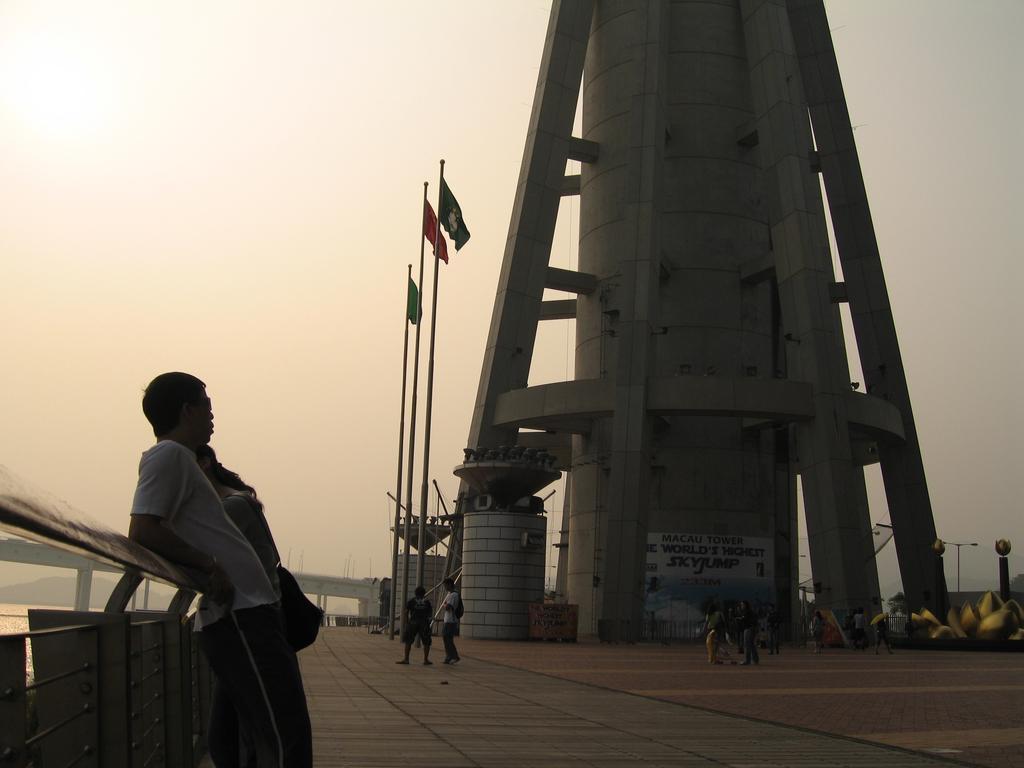Describe this image in one or two sentences. In this picture I can see group of people standing, there is a tower, there are flags with the poles, there is a bridge, there is water, and in the background there is the sky. 